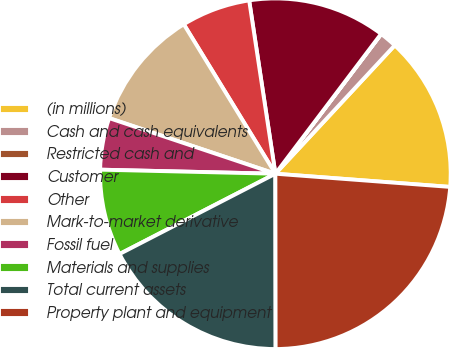Convert chart. <chart><loc_0><loc_0><loc_500><loc_500><pie_chart><fcel>(in millions)<fcel>Cash and cash equivalents<fcel>Restricted cash and<fcel>Customer<fcel>Other<fcel>Mark-to-market derivative<fcel>Fossil fuel<fcel>Materials and supplies<fcel>Total current assets<fcel>Property plant and equipment<nl><fcel>14.28%<fcel>1.6%<fcel>0.02%<fcel>12.69%<fcel>6.36%<fcel>11.11%<fcel>4.77%<fcel>7.94%<fcel>17.45%<fcel>23.78%<nl></chart> 